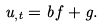Convert formula to latex. <formula><loc_0><loc_0><loc_500><loc_500>u _ { , t } = b \, f + g .</formula> 